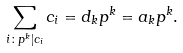Convert formula to latex. <formula><loc_0><loc_0><loc_500><loc_500>\sum _ { i \colon p ^ { k } | c _ { i } } c _ { i } = d _ { k } p ^ { k } = a _ { k } p ^ { k } .</formula> 